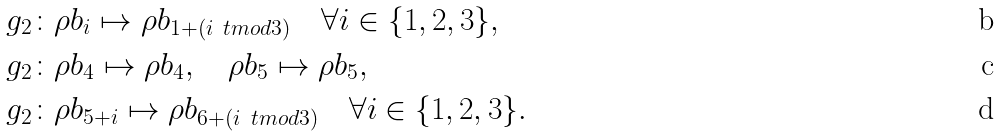<formula> <loc_0><loc_0><loc_500><loc_500>g _ { 2 } \colon & \rho b _ { i } \mapsto \rho b _ { 1 + ( i \ t m o d 3 ) } \quad \forall i \in \{ 1 , 2 , 3 \} , \\ g _ { 2 } \colon & \rho b _ { 4 } \mapsto \rho b _ { 4 } , \quad \rho b _ { 5 } \mapsto \rho b _ { 5 } , \\ g _ { 2 } \colon & \rho b _ { 5 + i } \mapsto \rho b _ { 6 + ( i \ t m o d 3 ) } \quad \forall i \in \{ 1 , 2 , 3 \} .</formula> 